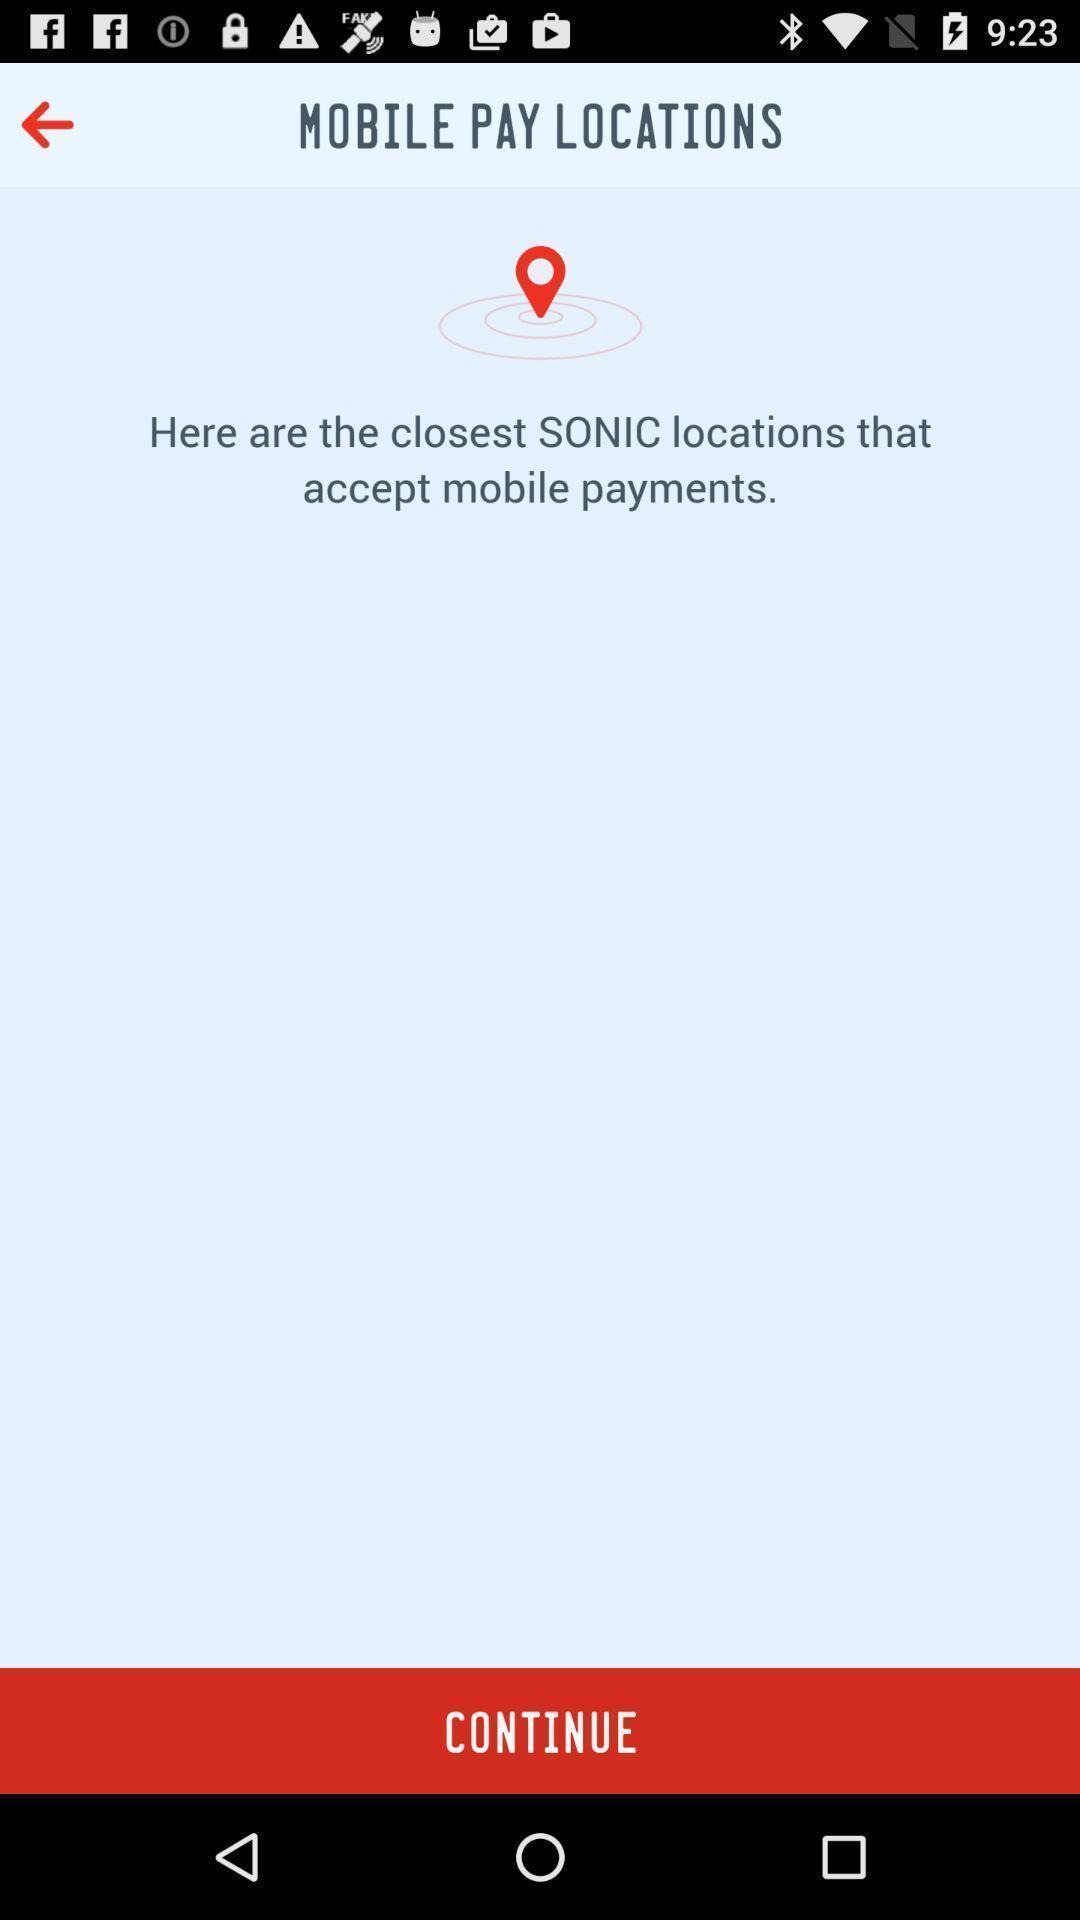What can you discern from this picture? Page shows to continue with financial app. 